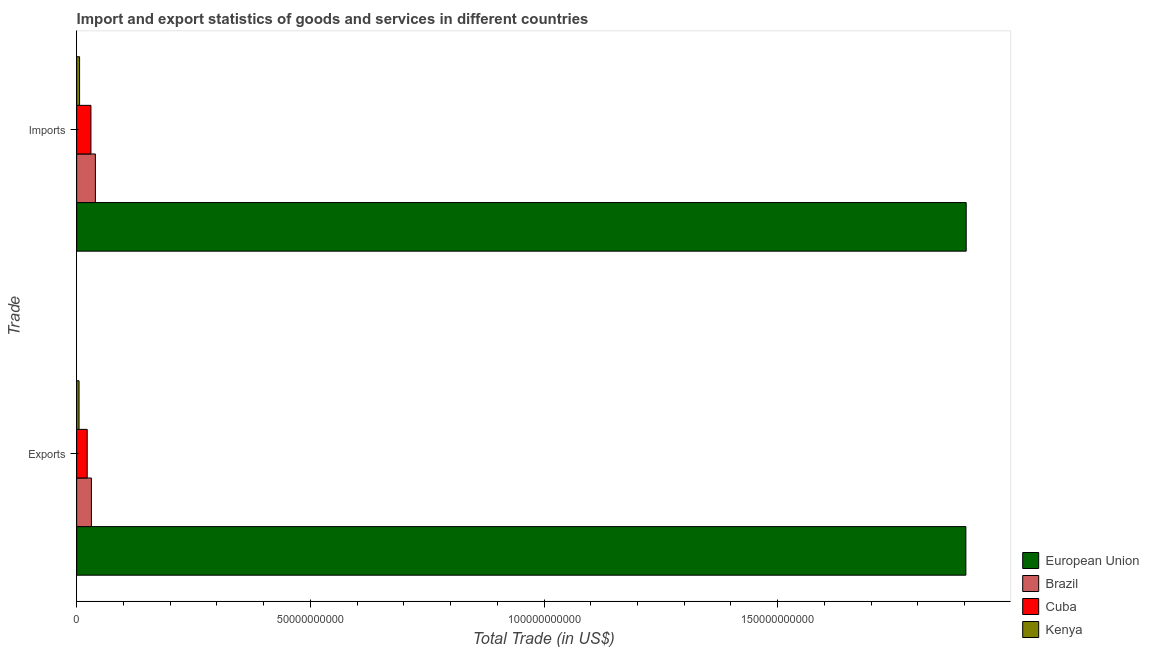How many different coloured bars are there?
Keep it short and to the point. 4. Are the number of bars per tick equal to the number of legend labels?
Your response must be concise. Yes. How many bars are there on the 2nd tick from the bottom?
Offer a very short reply. 4. What is the label of the 1st group of bars from the top?
Your answer should be very brief. Imports. What is the export of goods and services in European Union?
Give a very brief answer. 1.90e+11. Across all countries, what is the maximum imports of goods and services?
Your answer should be compact. 1.90e+11. Across all countries, what is the minimum imports of goods and services?
Offer a very short reply. 6.26e+08. In which country was the imports of goods and services minimum?
Ensure brevity in your answer.  Kenya. What is the total imports of goods and services in the graph?
Make the answer very short. 1.98e+11. What is the difference between the export of goods and services in European Union and that in Kenya?
Keep it short and to the point. 1.90e+11. What is the difference between the imports of goods and services in European Union and the export of goods and services in Cuba?
Your answer should be very brief. 1.88e+11. What is the average export of goods and services per country?
Give a very brief answer. 4.90e+1. What is the difference between the export of goods and services and imports of goods and services in Brazil?
Provide a short and direct response. -8.49e+08. What is the ratio of the imports of goods and services in Cuba to that in European Union?
Keep it short and to the point. 0.02. What does the 3rd bar from the top in Exports represents?
Your response must be concise. Brazil. What does the 4th bar from the bottom in Exports represents?
Ensure brevity in your answer.  Kenya. Does the graph contain any zero values?
Give a very brief answer. No. Where does the legend appear in the graph?
Give a very brief answer. Bottom right. How many legend labels are there?
Your answer should be very brief. 4. What is the title of the graph?
Give a very brief answer. Import and export statistics of goods and services in different countries. What is the label or title of the X-axis?
Keep it short and to the point. Total Trade (in US$). What is the label or title of the Y-axis?
Provide a succinct answer. Trade. What is the Total Trade (in US$) of European Union in Exports?
Provide a succinct answer. 1.90e+11. What is the Total Trade (in US$) of Brazil in Exports?
Give a very brief answer. 3.16e+09. What is the Total Trade (in US$) in Cuba in Exports?
Your answer should be compact. 2.26e+09. What is the Total Trade (in US$) of Kenya in Exports?
Your response must be concise. 5.09e+08. What is the Total Trade (in US$) in European Union in Imports?
Keep it short and to the point. 1.90e+11. What is the Total Trade (in US$) in Brazil in Imports?
Keep it short and to the point. 4.00e+09. What is the Total Trade (in US$) of Cuba in Imports?
Your answer should be very brief. 3.06e+09. What is the Total Trade (in US$) of Kenya in Imports?
Offer a very short reply. 6.26e+08. Across all Trade, what is the maximum Total Trade (in US$) of European Union?
Give a very brief answer. 1.90e+11. Across all Trade, what is the maximum Total Trade (in US$) of Brazil?
Offer a very short reply. 4.00e+09. Across all Trade, what is the maximum Total Trade (in US$) in Cuba?
Provide a short and direct response. 3.06e+09. Across all Trade, what is the maximum Total Trade (in US$) in Kenya?
Your answer should be compact. 6.26e+08. Across all Trade, what is the minimum Total Trade (in US$) of European Union?
Offer a terse response. 1.90e+11. Across all Trade, what is the minimum Total Trade (in US$) in Brazil?
Ensure brevity in your answer.  3.16e+09. Across all Trade, what is the minimum Total Trade (in US$) of Cuba?
Offer a very short reply. 2.26e+09. Across all Trade, what is the minimum Total Trade (in US$) of Kenya?
Your answer should be compact. 5.09e+08. What is the total Total Trade (in US$) of European Union in the graph?
Make the answer very short. 3.81e+11. What is the total Total Trade (in US$) in Brazil in the graph?
Your answer should be compact. 7.16e+09. What is the total Total Trade (in US$) in Cuba in the graph?
Ensure brevity in your answer.  5.31e+09. What is the total Total Trade (in US$) of Kenya in the graph?
Offer a terse response. 1.14e+09. What is the difference between the Total Trade (in US$) of European Union in Exports and that in Imports?
Your answer should be compact. -7.02e+07. What is the difference between the Total Trade (in US$) in Brazil in Exports and that in Imports?
Your answer should be very brief. -8.49e+08. What is the difference between the Total Trade (in US$) of Cuba in Exports and that in Imports?
Offer a very short reply. -7.99e+08. What is the difference between the Total Trade (in US$) in Kenya in Exports and that in Imports?
Your answer should be compact. -1.16e+08. What is the difference between the Total Trade (in US$) in European Union in Exports and the Total Trade (in US$) in Brazil in Imports?
Your answer should be very brief. 1.86e+11. What is the difference between the Total Trade (in US$) of European Union in Exports and the Total Trade (in US$) of Cuba in Imports?
Offer a very short reply. 1.87e+11. What is the difference between the Total Trade (in US$) of European Union in Exports and the Total Trade (in US$) of Kenya in Imports?
Provide a succinct answer. 1.90e+11. What is the difference between the Total Trade (in US$) in Brazil in Exports and the Total Trade (in US$) in Cuba in Imports?
Offer a terse response. 1.01e+08. What is the difference between the Total Trade (in US$) of Brazil in Exports and the Total Trade (in US$) of Kenya in Imports?
Make the answer very short. 2.53e+09. What is the difference between the Total Trade (in US$) in Cuba in Exports and the Total Trade (in US$) in Kenya in Imports?
Give a very brief answer. 1.63e+09. What is the average Total Trade (in US$) in European Union per Trade?
Make the answer very short. 1.90e+11. What is the average Total Trade (in US$) in Brazil per Trade?
Offer a terse response. 3.58e+09. What is the average Total Trade (in US$) in Cuba per Trade?
Give a very brief answer. 2.66e+09. What is the average Total Trade (in US$) of Kenya per Trade?
Your answer should be very brief. 5.68e+08. What is the difference between the Total Trade (in US$) of European Union and Total Trade (in US$) of Brazil in Exports?
Make the answer very short. 1.87e+11. What is the difference between the Total Trade (in US$) of European Union and Total Trade (in US$) of Cuba in Exports?
Provide a succinct answer. 1.88e+11. What is the difference between the Total Trade (in US$) of European Union and Total Trade (in US$) of Kenya in Exports?
Your answer should be compact. 1.90e+11. What is the difference between the Total Trade (in US$) in Brazil and Total Trade (in US$) in Cuba in Exports?
Your answer should be compact. 9.00e+08. What is the difference between the Total Trade (in US$) in Brazil and Total Trade (in US$) in Kenya in Exports?
Offer a terse response. 2.65e+09. What is the difference between the Total Trade (in US$) in Cuba and Total Trade (in US$) in Kenya in Exports?
Your answer should be very brief. 1.75e+09. What is the difference between the Total Trade (in US$) in European Union and Total Trade (in US$) in Brazil in Imports?
Make the answer very short. 1.86e+11. What is the difference between the Total Trade (in US$) of European Union and Total Trade (in US$) of Cuba in Imports?
Provide a succinct answer. 1.87e+11. What is the difference between the Total Trade (in US$) of European Union and Total Trade (in US$) of Kenya in Imports?
Your answer should be compact. 1.90e+11. What is the difference between the Total Trade (in US$) in Brazil and Total Trade (in US$) in Cuba in Imports?
Offer a terse response. 9.49e+08. What is the difference between the Total Trade (in US$) in Brazil and Total Trade (in US$) in Kenya in Imports?
Provide a short and direct response. 3.38e+09. What is the difference between the Total Trade (in US$) of Cuba and Total Trade (in US$) of Kenya in Imports?
Give a very brief answer. 2.43e+09. What is the ratio of the Total Trade (in US$) in Brazil in Exports to that in Imports?
Offer a very short reply. 0.79. What is the ratio of the Total Trade (in US$) in Cuba in Exports to that in Imports?
Provide a succinct answer. 0.74. What is the ratio of the Total Trade (in US$) in Kenya in Exports to that in Imports?
Provide a short and direct response. 0.81. What is the difference between the highest and the second highest Total Trade (in US$) in European Union?
Your answer should be very brief. 7.02e+07. What is the difference between the highest and the second highest Total Trade (in US$) of Brazil?
Offer a very short reply. 8.49e+08. What is the difference between the highest and the second highest Total Trade (in US$) of Cuba?
Offer a terse response. 7.99e+08. What is the difference between the highest and the second highest Total Trade (in US$) of Kenya?
Give a very brief answer. 1.16e+08. What is the difference between the highest and the lowest Total Trade (in US$) of European Union?
Your answer should be very brief. 7.02e+07. What is the difference between the highest and the lowest Total Trade (in US$) of Brazil?
Provide a succinct answer. 8.49e+08. What is the difference between the highest and the lowest Total Trade (in US$) in Cuba?
Offer a terse response. 7.99e+08. What is the difference between the highest and the lowest Total Trade (in US$) in Kenya?
Your response must be concise. 1.16e+08. 